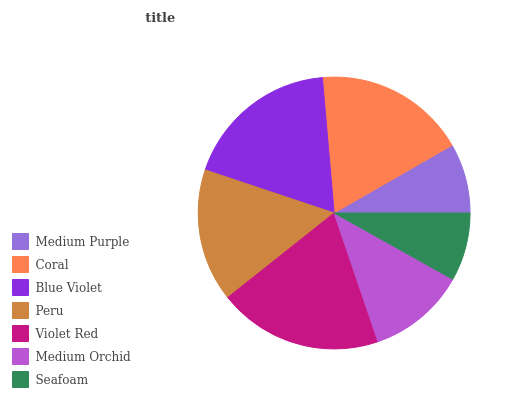Is Seafoam the minimum?
Answer yes or no. Yes. Is Violet Red the maximum?
Answer yes or no. Yes. Is Coral the minimum?
Answer yes or no. No. Is Coral the maximum?
Answer yes or no. No. Is Coral greater than Medium Purple?
Answer yes or no. Yes. Is Medium Purple less than Coral?
Answer yes or no. Yes. Is Medium Purple greater than Coral?
Answer yes or no. No. Is Coral less than Medium Purple?
Answer yes or no. No. Is Peru the high median?
Answer yes or no. Yes. Is Peru the low median?
Answer yes or no. Yes. Is Seafoam the high median?
Answer yes or no. No. Is Blue Violet the low median?
Answer yes or no. No. 